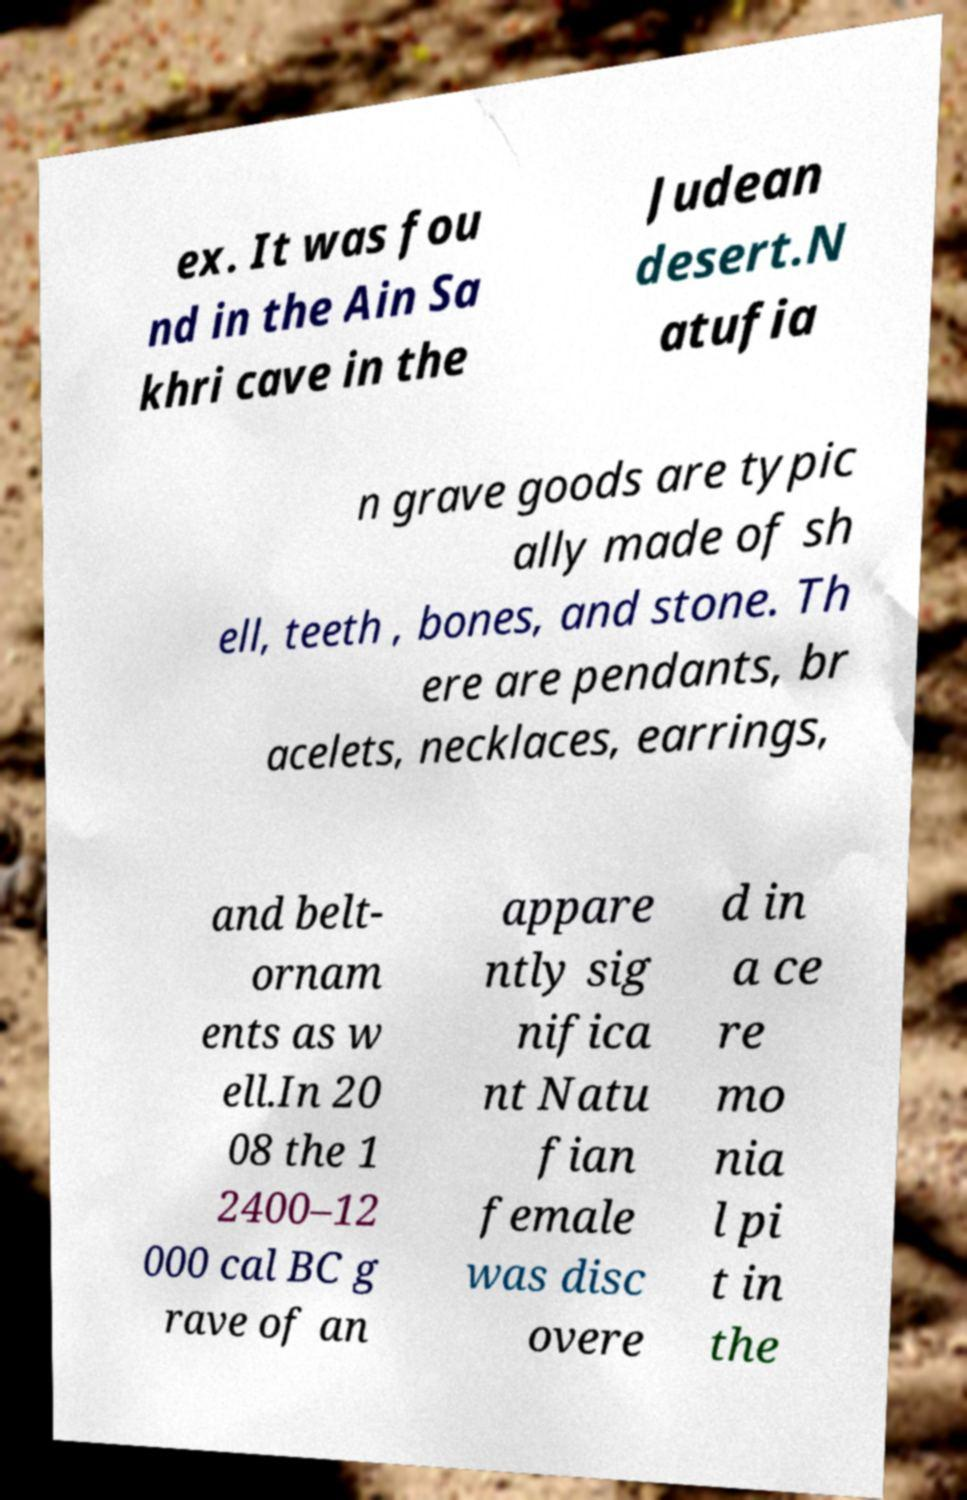For documentation purposes, I need the text within this image transcribed. Could you provide that? ex. It was fou nd in the Ain Sa khri cave in the Judean desert.N atufia n grave goods are typic ally made of sh ell, teeth , bones, and stone. Th ere are pendants, br acelets, necklaces, earrings, and belt- ornam ents as w ell.In 20 08 the 1 2400–12 000 cal BC g rave of an appare ntly sig nifica nt Natu fian female was disc overe d in a ce re mo nia l pi t in the 